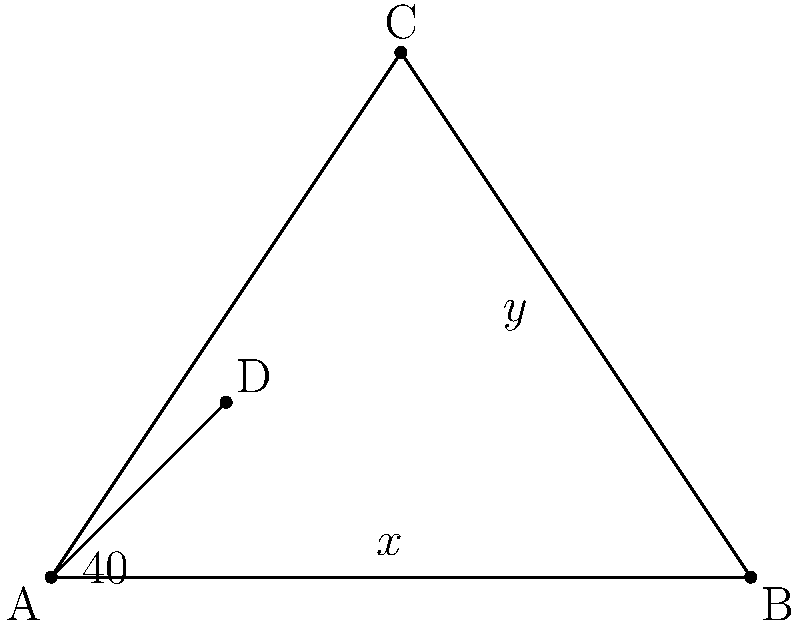In the diagram above, roads AB, AC, and AD lead to different cannabis dispensary locations. If angle BAD is 40°, and angle ADB is x°, what is the value of y° in terms of x? Let's approach this step-by-step:

1) In triangle ACD, we need to find angle ACD (y°).

2) We know that the sum of angles in a triangle is 180°. So in triangle ABD:
   $40° + x° + \angle ADB = 180°$

3) Angle ADB is the same as angle BDC because they form a straight line (180°).
   So, $\angle BDC = 180° - (40° + x°) = 140° - x°$

4) Now, in triangle ACD:
   $y° + (140° - x°) + \angle CAD = 180°$

5) We don't know angle CAD, but we can find it. In triangle ABC:
   $40° + \angle CAB + 90° = 180°$ (because ABC is a right triangle)
   $\angle CAB = 50°$

6) So, angle CAD = 50° - 40° = 10°

7) Substituting this back into the equation from step 4:
   $y° + (140° - x°) + 10° = 180°$

8) Simplifying:
   $y° = 180° - (140° - x°) - 10°$
   $y° = 180° - 140° + x° - 10°$
   $y° = 30° + x°$

Therefore, $y = 30 + x$.
Answer: $y = 30 + x$ 